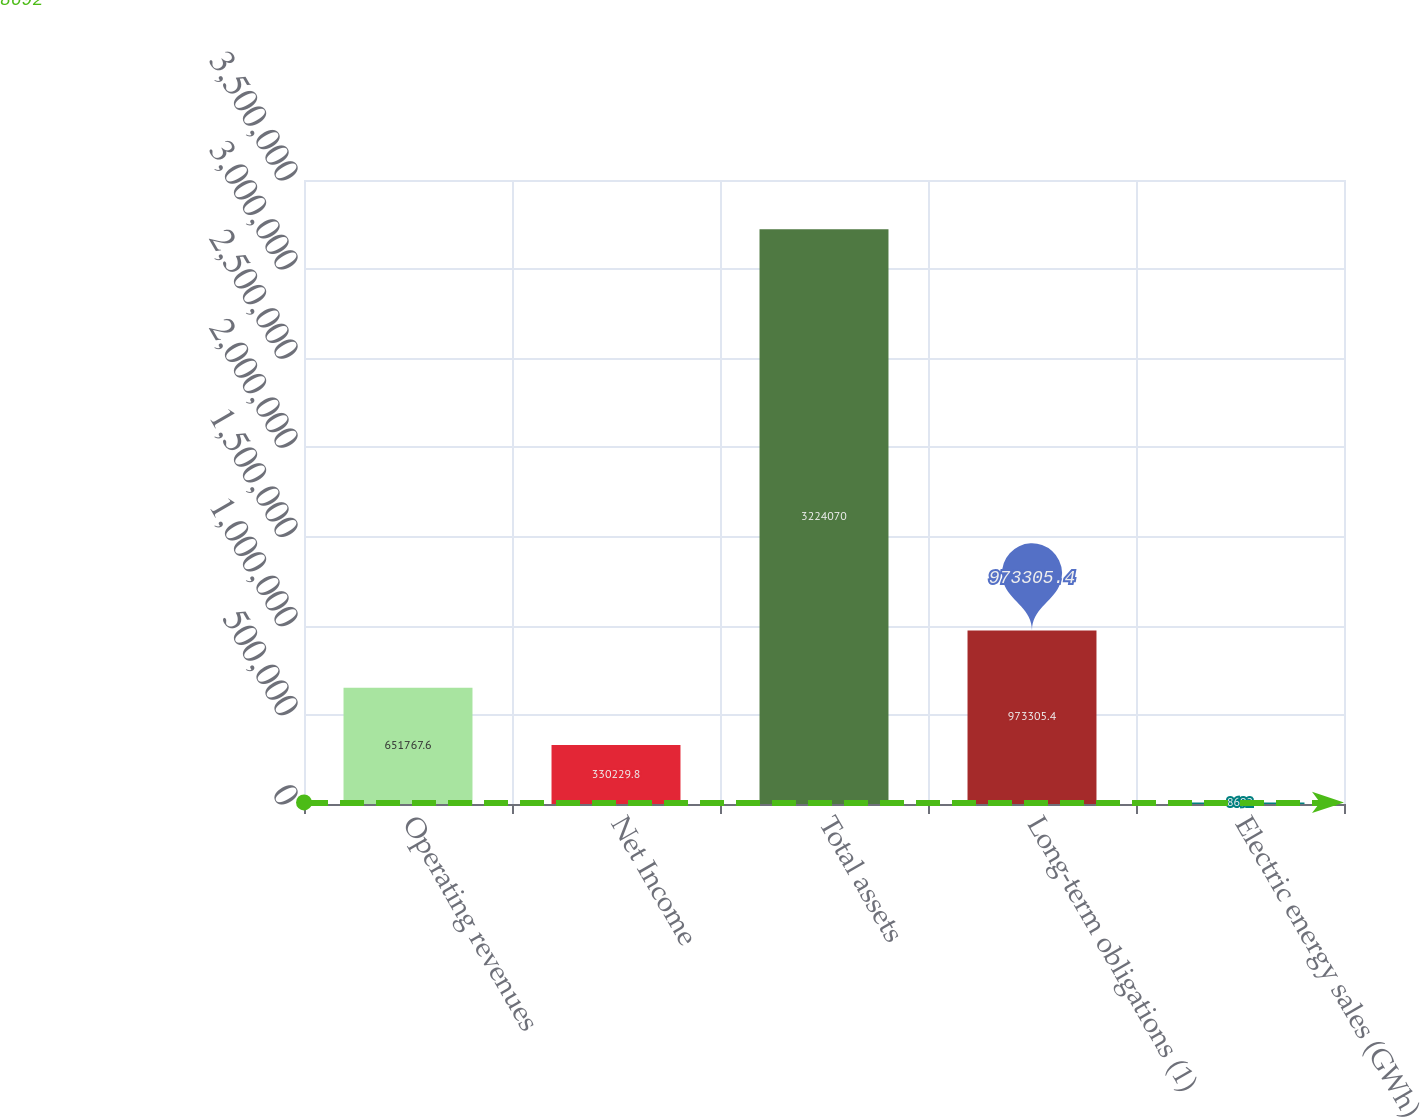<chart> <loc_0><loc_0><loc_500><loc_500><bar_chart><fcel>Operating revenues<fcel>Net Income<fcel>Total assets<fcel>Long-term obligations (1)<fcel>Electric energy sales (GWh)<nl><fcel>651768<fcel>330230<fcel>3.22407e+06<fcel>973305<fcel>8692<nl></chart> 